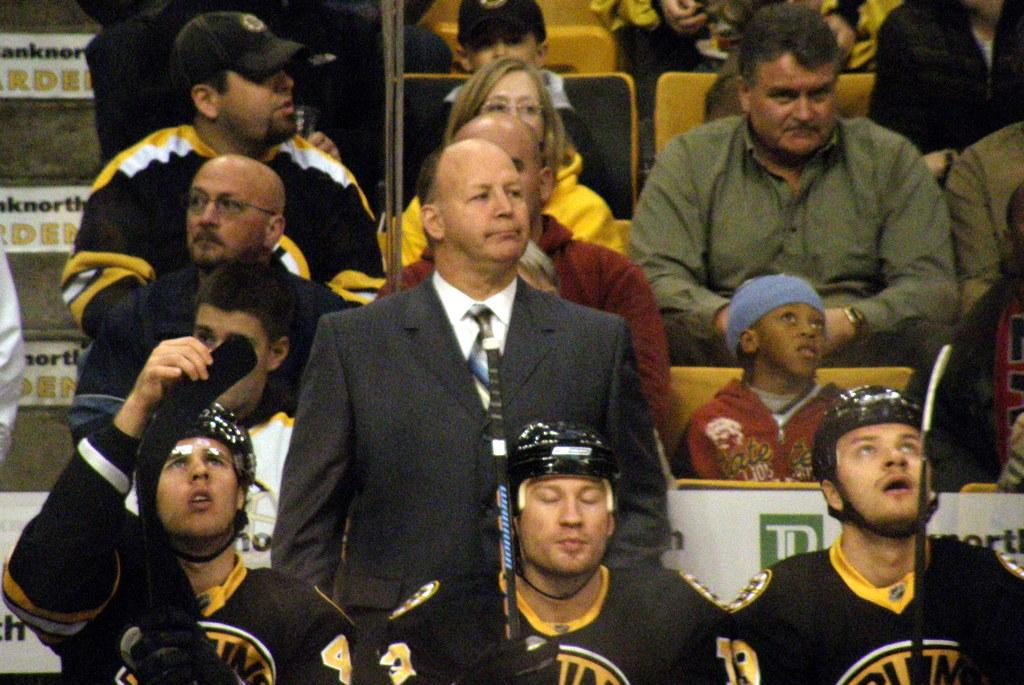How many people are in the image? There are many people in the image. What are the people doing in the image? The people are sitting in chairs. What are the majority of the people wearing? Most of the people are wearing black and yellow jerseys. Can you describe the person standing in the middle of the image? There is a person in a grey suit standing in the middle of the image. What type of robin can be seen wearing a skirt in the image? There is no robin or skirt present in the image. What is the average income of the people in the image? The provided facts do not include information about the people's income, so it cannot be determined from the image. 